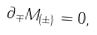Convert formula to latex. <formula><loc_0><loc_0><loc_500><loc_500>\partial _ { \mp } M _ { ( \pm ) } = 0 ,</formula> 